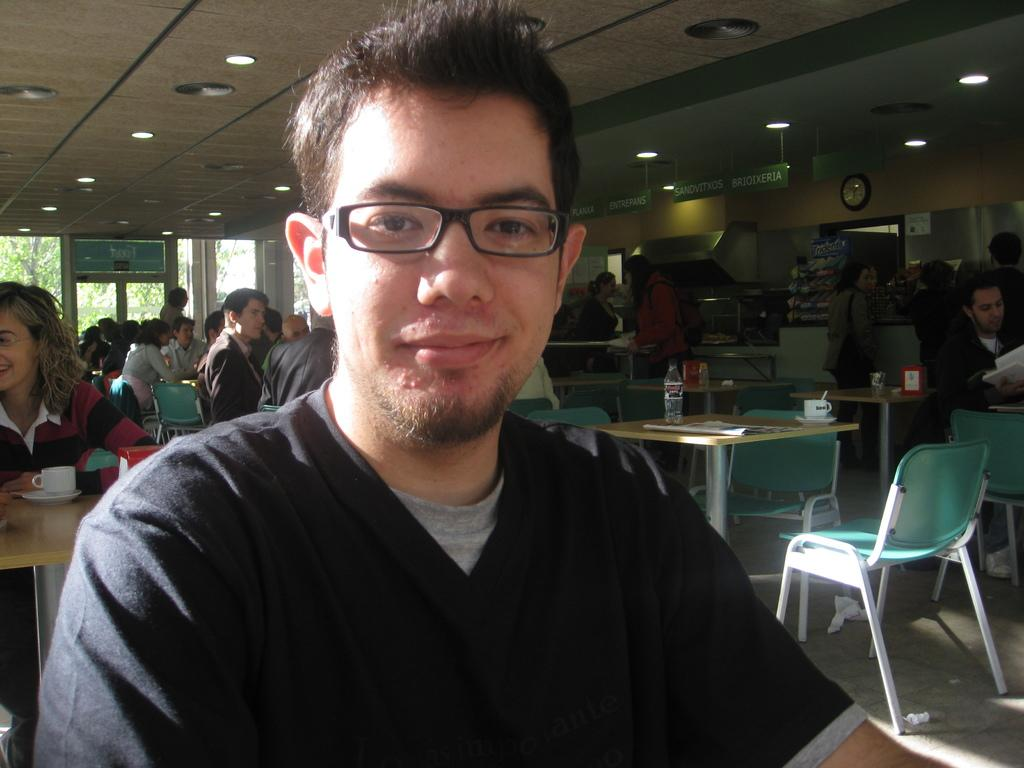What is the color of the wall in the image? The wall in the image is white. What object can be used to tell time in the image? There is a clock in the image. What type of decoration is hanging in the image? There is a banner in the image. What are the people in the image doing? The people in the image are sitting on chairs. What type of furniture is present in the image? There are tables in the image. What items can be found on the tables? Newspapers, a bottle, and a cup are present on the tables. What type of powder is being used to clean the clock in the image? There is no powder or cleaning activity depicted in the image; the clock is simply present. What color is the dress worn by the person sitting on the chair in the image? There is no person wearing a dress in the image; the people are sitting on chairs, but their clothing is not specified. 